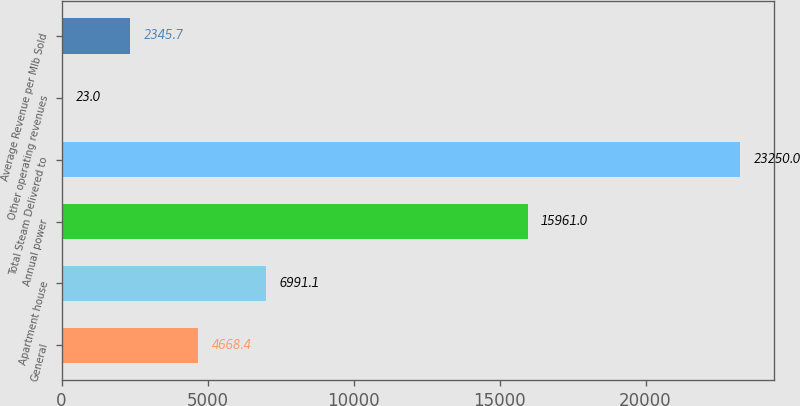<chart> <loc_0><loc_0><loc_500><loc_500><bar_chart><fcel>General<fcel>Apartment house<fcel>Annual power<fcel>Total Steam Delivered to<fcel>Other operating revenues<fcel>Average Revenue per Mlb Sold<nl><fcel>4668.4<fcel>6991.1<fcel>15961<fcel>23250<fcel>23<fcel>2345.7<nl></chart> 